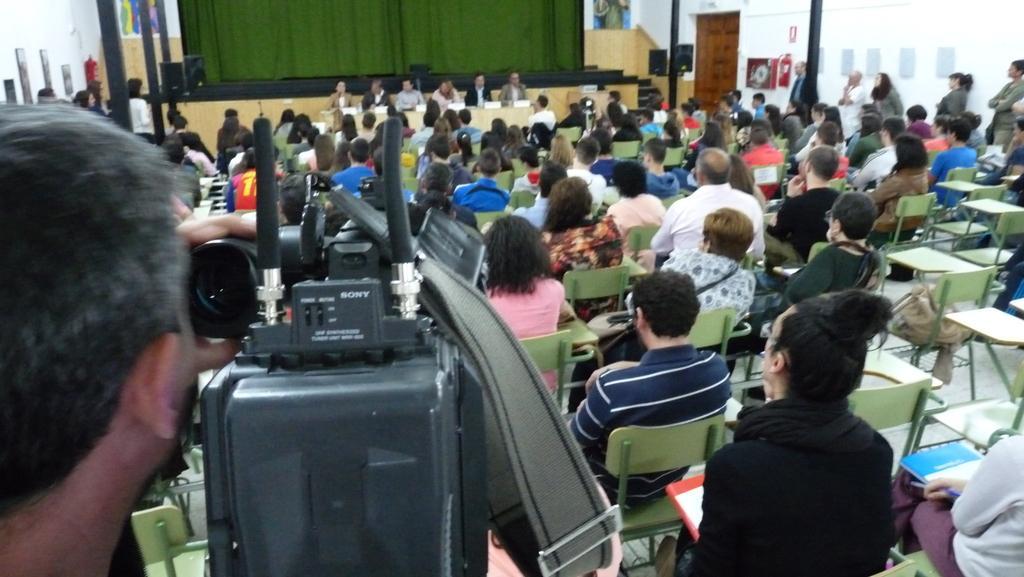Could you give a brief overview of what you see in this image? In the foreground of the image we can see a person is recording the event with a camera. In the middle of the image we can see some persons are sitting on the chairs. On the top of the image we can see some persons are sitting, a stage and curtains are there. 